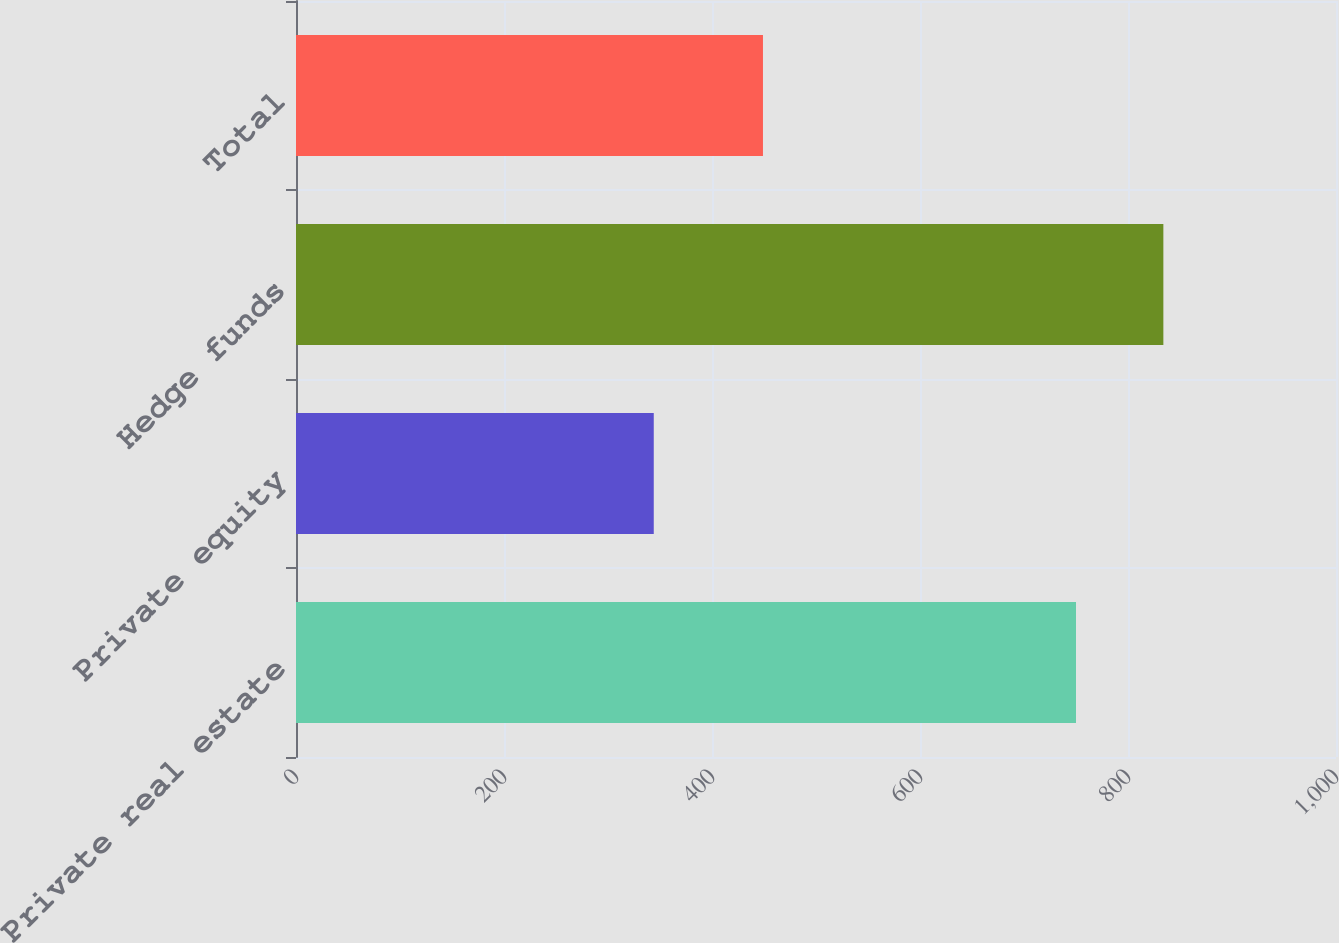<chart> <loc_0><loc_0><loc_500><loc_500><bar_chart><fcel>Private real estate<fcel>Private equity<fcel>Hedge funds<fcel>Total<nl><fcel>750<fcel>344<fcel>834<fcel>449<nl></chart> 